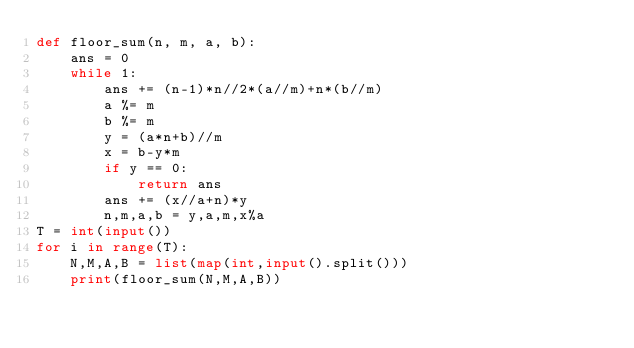<code> <loc_0><loc_0><loc_500><loc_500><_Python_>def floor_sum(n, m, a, b):
    ans = 0
    while 1:
        ans += (n-1)*n//2*(a//m)+n*(b//m)
        a %= m
        b %= m
        y = (a*n+b)//m
        x = b-y*m
        if y == 0:
            return ans
        ans += (x//a+n)*y
        n,m,a,b = y,a,m,x%a
T = int(input())
for i in range(T):
    N,M,A,B = list(map(int,input().split()))
    print(floor_sum(N,M,A,B))
</code> 